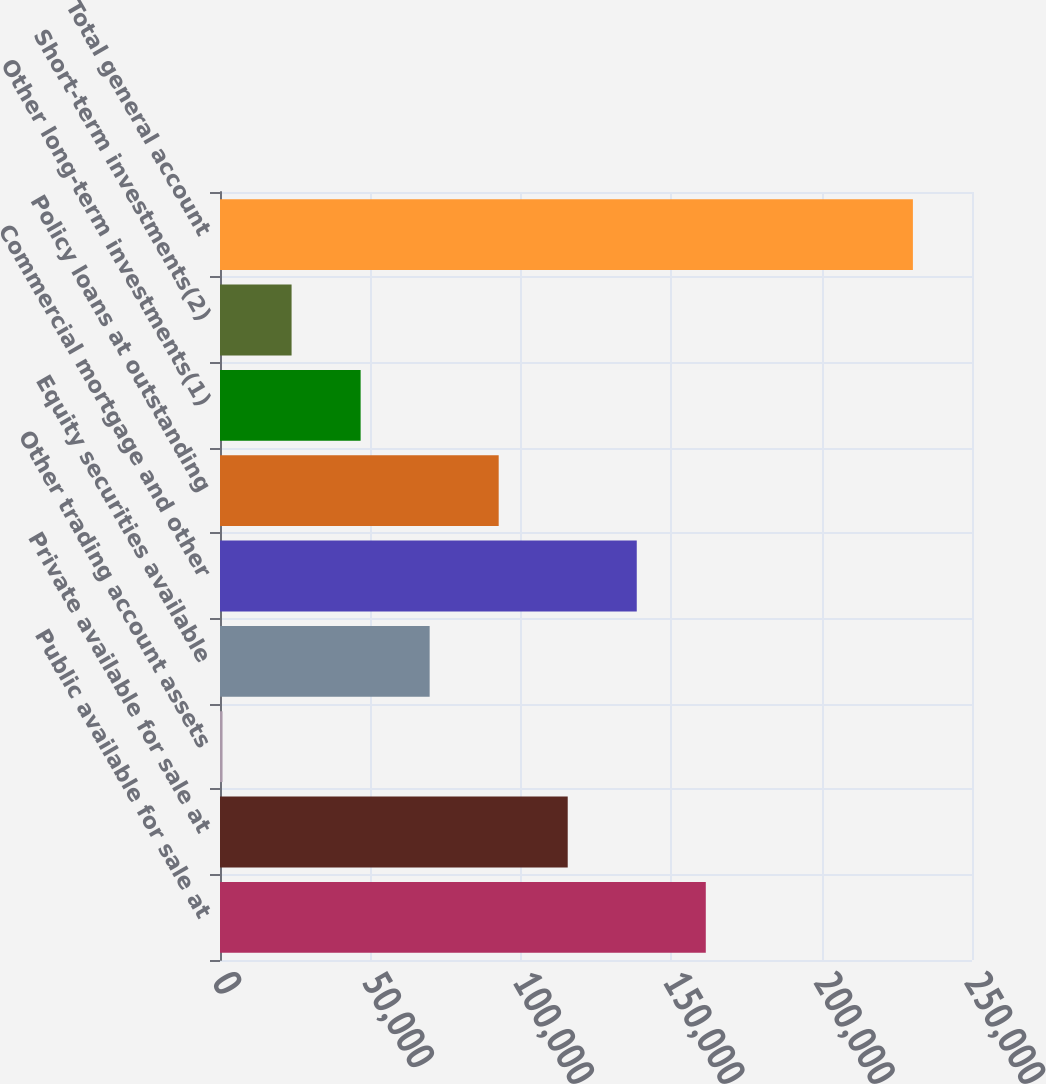Convert chart to OTSL. <chart><loc_0><loc_0><loc_500><loc_500><bar_chart><fcel>Public available for sale at<fcel>Private available for sale at<fcel>Other trading account assets<fcel>Equity securities available<fcel>Commercial mortgage and other<fcel>Policy loans at outstanding<fcel>Other long-term investments(1)<fcel>Short-term investments(2)<fcel>Total general account<nl><fcel>161500<fcel>115600<fcel>848<fcel>69698.9<fcel>138550<fcel>92649.2<fcel>46748.6<fcel>23798.3<fcel>230351<nl></chart> 